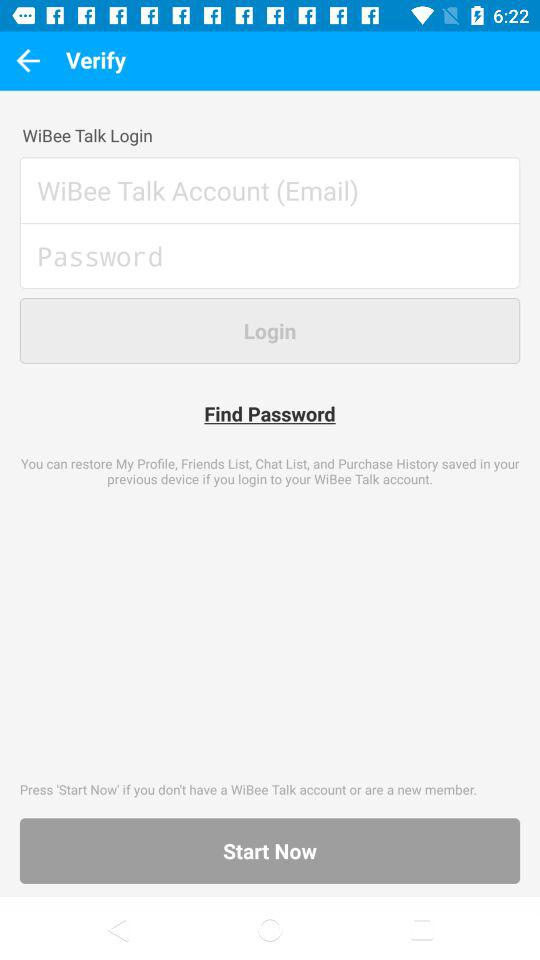How many characters are required to create a password?
When the provided information is insufficient, respond with <no answer>. <no answer> 